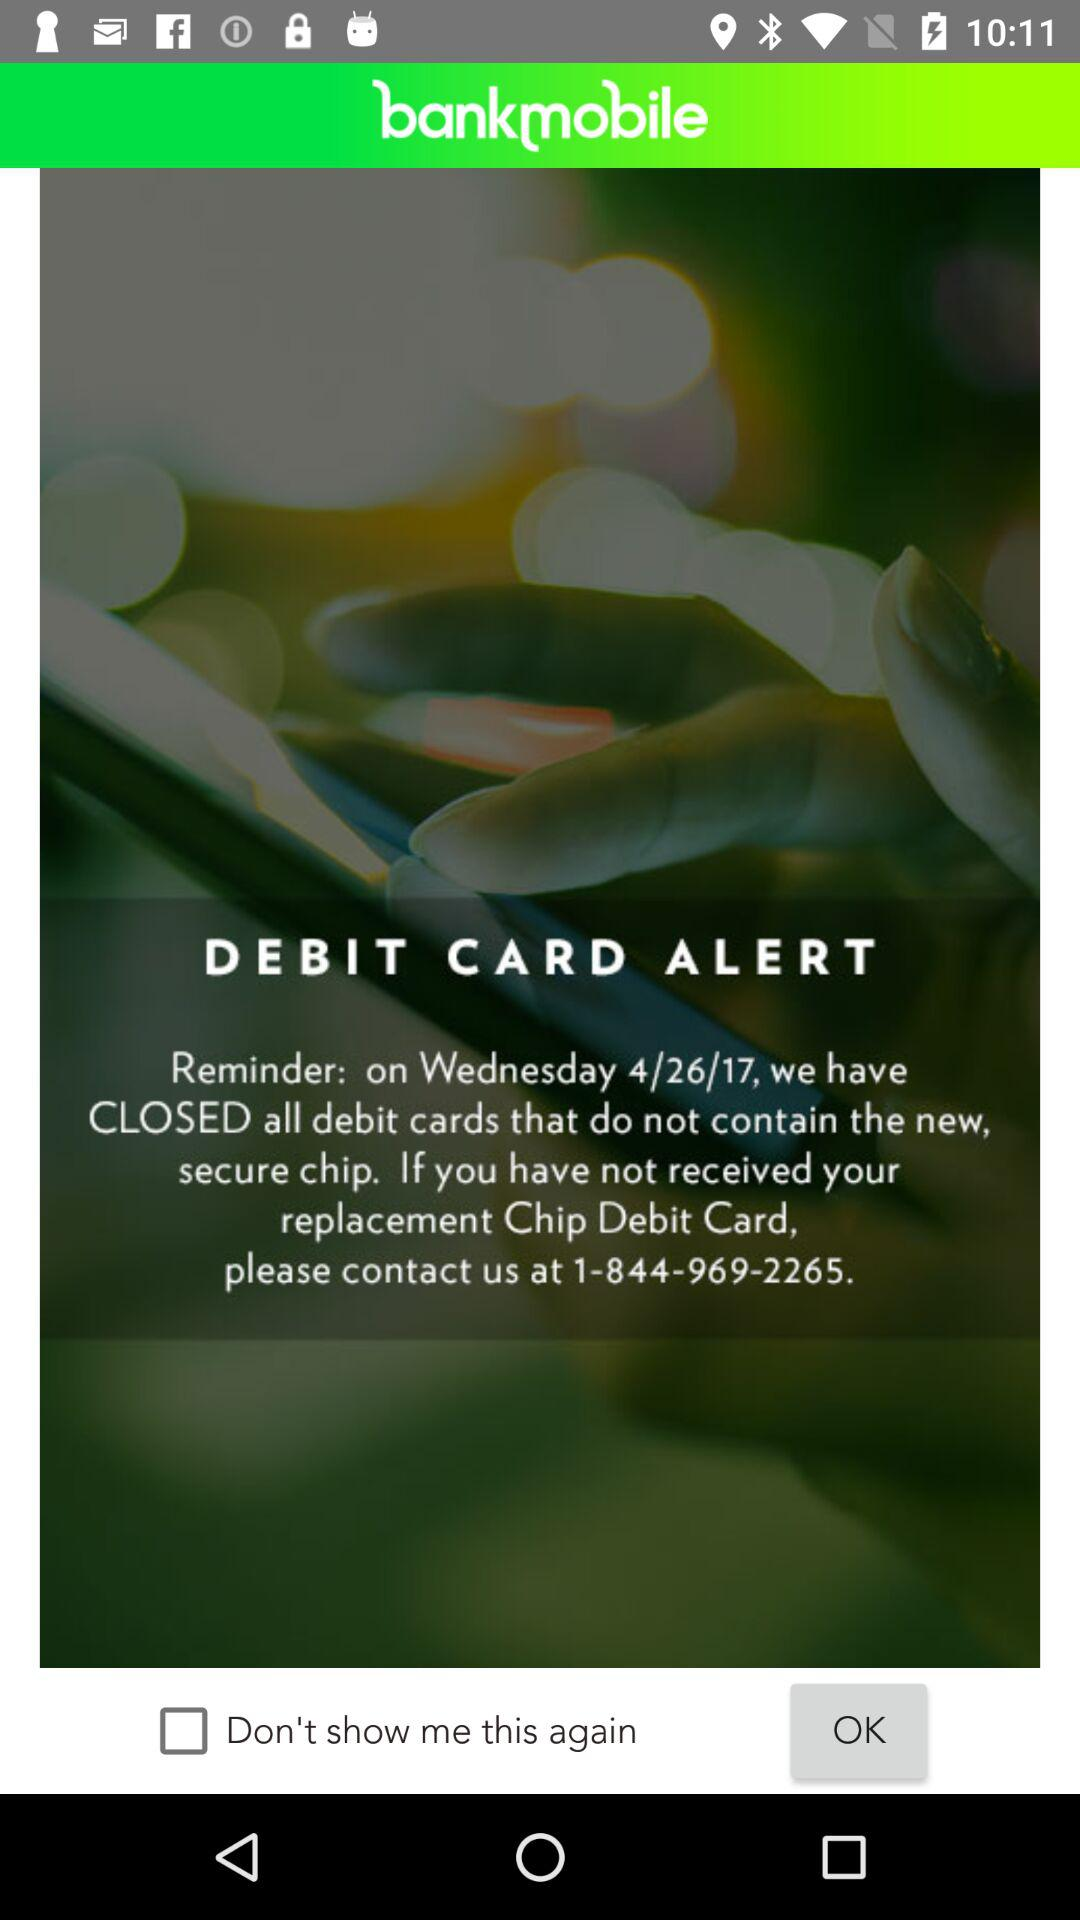What is the application name? The application name is "bankmobile". 